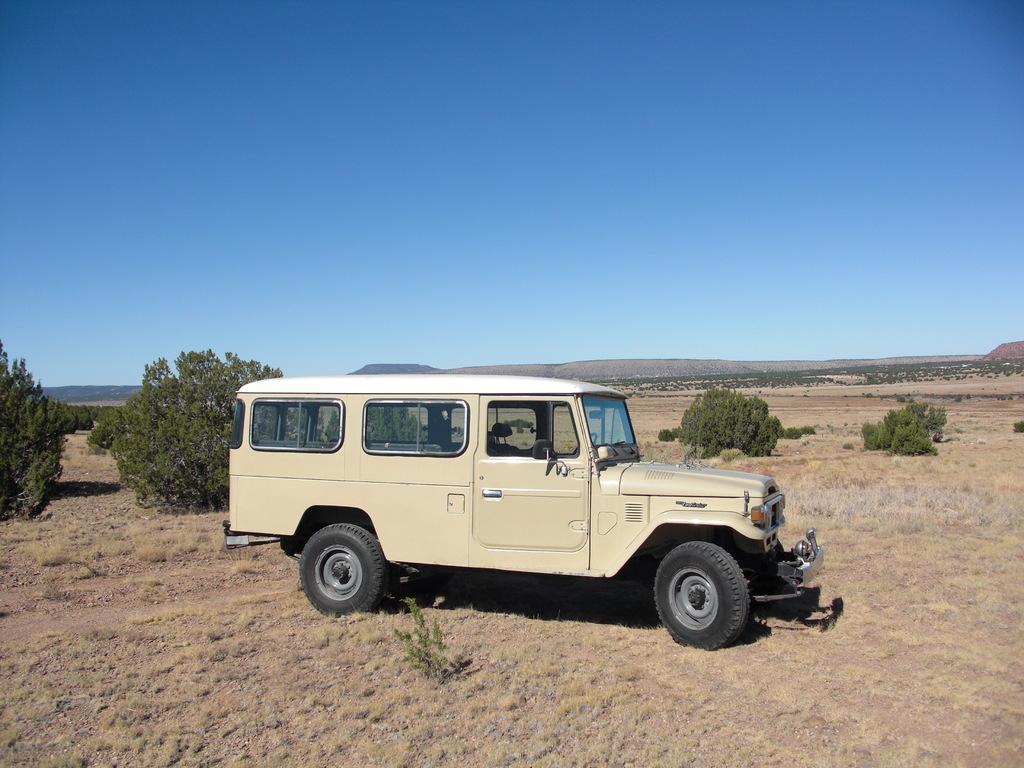In one or two sentences, can you explain what this image depicts? In the foreground of the picture there are shrubs, plant and a car. In the center of the picture there are trees and shrubs. In the background there are trees and other objects. Sky is sunny. 